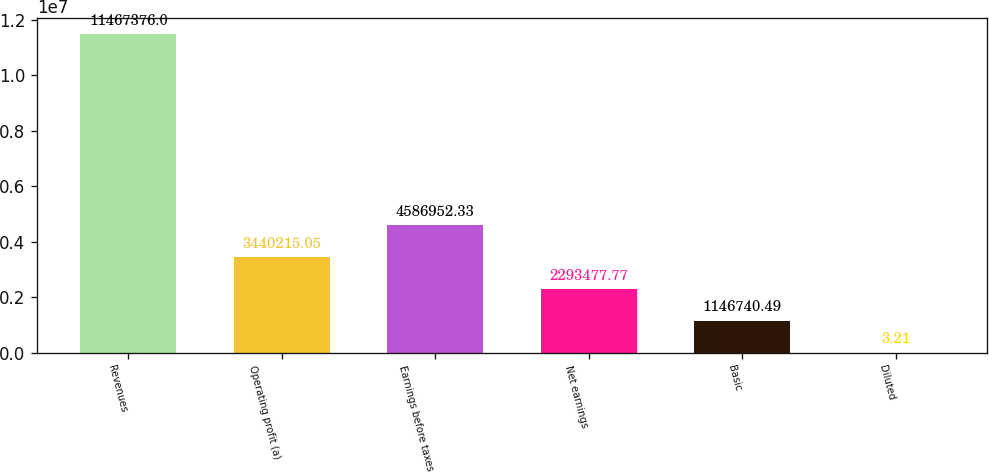Convert chart. <chart><loc_0><loc_0><loc_500><loc_500><bar_chart><fcel>Revenues<fcel>Operating profit (a)<fcel>Earnings before taxes<fcel>Net earnings<fcel>Basic<fcel>Diluted<nl><fcel>1.14674e+07<fcel>3.44022e+06<fcel>4.58695e+06<fcel>2.29348e+06<fcel>1.14674e+06<fcel>3.21<nl></chart> 